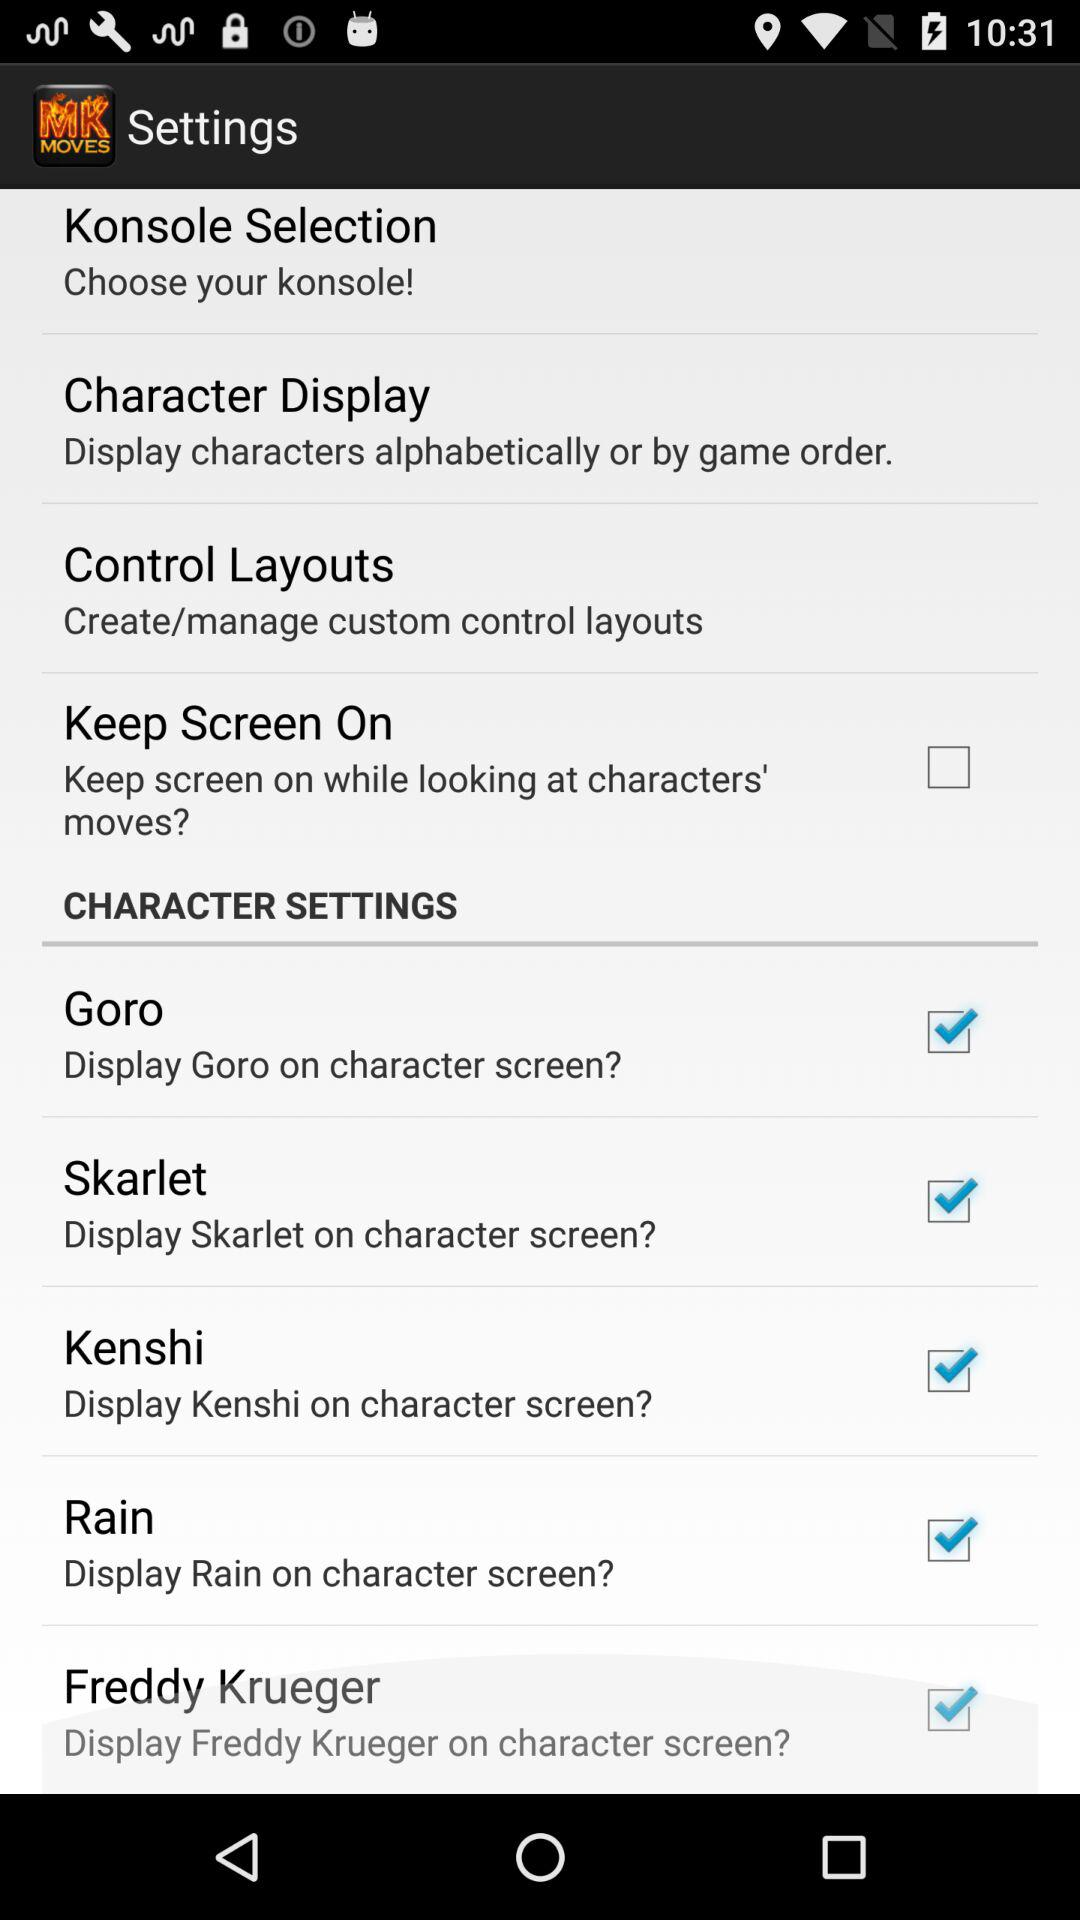What is the current status of "Keep Screen On"? The current status is "off". 